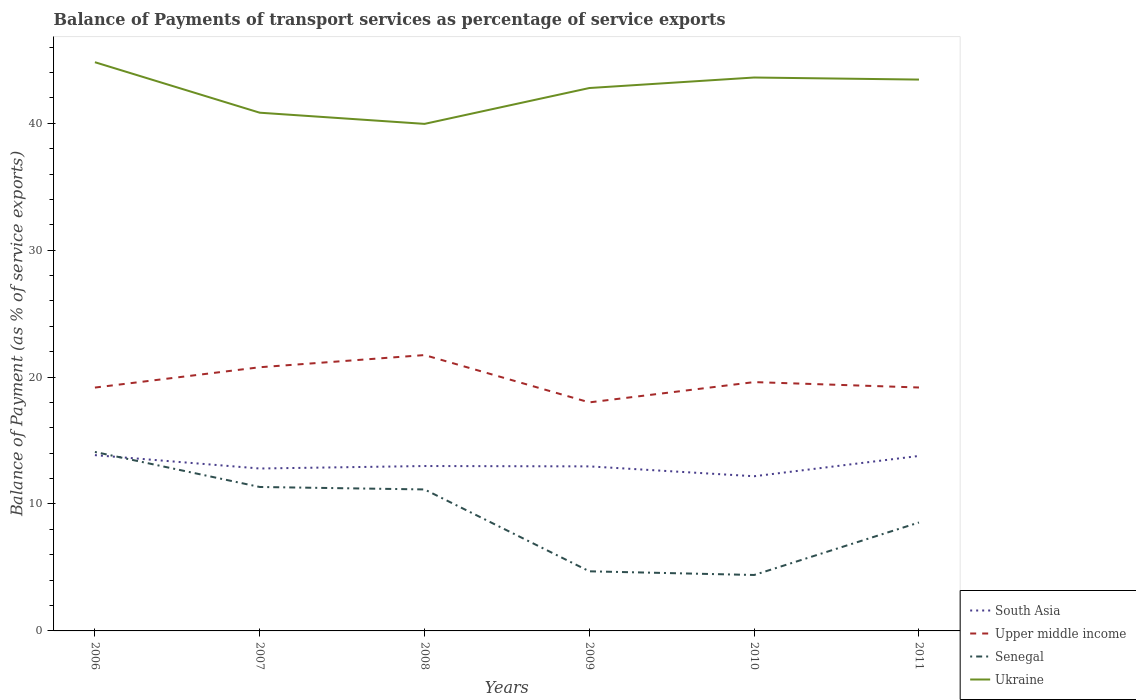Does the line corresponding to Upper middle income intersect with the line corresponding to Senegal?
Offer a terse response. No. Across all years, what is the maximum balance of payments of transport services in Ukraine?
Your answer should be compact. 39.95. In which year was the balance of payments of transport services in South Asia maximum?
Offer a very short reply. 2010. What is the total balance of payments of transport services in Ukraine in the graph?
Your answer should be compact. -3.65. What is the difference between the highest and the second highest balance of payments of transport services in Ukraine?
Provide a short and direct response. 4.86. Is the balance of payments of transport services in Upper middle income strictly greater than the balance of payments of transport services in Senegal over the years?
Your answer should be very brief. No. Are the values on the major ticks of Y-axis written in scientific E-notation?
Offer a very short reply. No. Does the graph contain any zero values?
Your answer should be compact. No. Does the graph contain grids?
Provide a succinct answer. No. How are the legend labels stacked?
Make the answer very short. Vertical. What is the title of the graph?
Ensure brevity in your answer.  Balance of Payments of transport services as percentage of service exports. What is the label or title of the X-axis?
Your answer should be very brief. Years. What is the label or title of the Y-axis?
Your answer should be compact. Balance of Payment (as % of service exports). What is the Balance of Payment (as % of service exports) of South Asia in 2006?
Offer a very short reply. 13.85. What is the Balance of Payment (as % of service exports) of Upper middle income in 2006?
Keep it short and to the point. 19.17. What is the Balance of Payment (as % of service exports) in Senegal in 2006?
Keep it short and to the point. 14.1. What is the Balance of Payment (as % of service exports) in Ukraine in 2006?
Your response must be concise. 44.81. What is the Balance of Payment (as % of service exports) in South Asia in 2007?
Keep it short and to the point. 12.8. What is the Balance of Payment (as % of service exports) in Upper middle income in 2007?
Make the answer very short. 20.77. What is the Balance of Payment (as % of service exports) of Senegal in 2007?
Your answer should be compact. 11.34. What is the Balance of Payment (as % of service exports) of Ukraine in 2007?
Keep it short and to the point. 40.83. What is the Balance of Payment (as % of service exports) of South Asia in 2008?
Your answer should be compact. 12.99. What is the Balance of Payment (as % of service exports) of Upper middle income in 2008?
Give a very brief answer. 21.73. What is the Balance of Payment (as % of service exports) in Senegal in 2008?
Provide a short and direct response. 11.15. What is the Balance of Payment (as % of service exports) in Ukraine in 2008?
Your response must be concise. 39.95. What is the Balance of Payment (as % of service exports) in South Asia in 2009?
Provide a short and direct response. 12.96. What is the Balance of Payment (as % of service exports) of Upper middle income in 2009?
Keep it short and to the point. 18.01. What is the Balance of Payment (as % of service exports) in Senegal in 2009?
Offer a terse response. 4.7. What is the Balance of Payment (as % of service exports) in Ukraine in 2009?
Make the answer very short. 42.77. What is the Balance of Payment (as % of service exports) of South Asia in 2010?
Your answer should be very brief. 12.19. What is the Balance of Payment (as % of service exports) of Upper middle income in 2010?
Offer a very short reply. 19.6. What is the Balance of Payment (as % of service exports) in Senegal in 2010?
Offer a terse response. 4.41. What is the Balance of Payment (as % of service exports) of Ukraine in 2010?
Make the answer very short. 43.6. What is the Balance of Payment (as % of service exports) in South Asia in 2011?
Keep it short and to the point. 13.79. What is the Balance of Payment (as % of service exports) in Upper middle income in 2011?
Offer a very short reply. 19.18. What is the Balance of Payment (as % of service exports) in Senegal in 2011?
Your answer should be compact. 8.54. What is the Balance of Payment (as % of service exports) of Ukraine in 2011?
Your response must be concise. 43.44. Across all years, what is the maximum Balance of Payment (as % of service exports) of South Asia?
Give a very brief answer. 13.85. Across all years, what is the maximum Balance of Payment (as % of service exports) in Upper middle income?
Your answer should be compact. 21.73. Across all years, what is the maximum Balance of Payment (as % of service exports) of Senegal?
Provide a succinct answer. 14.1. Across all years, what is the maximum Balance of Payment (as % of service exports) in Ukraine?
Your response must be concise. 44.81. Across all years, what is the minimum Balance of Payment (as % of service exports) of South Asia?
Your response must be concise. 12.19. Across all years, what is the minimum Balance of Payment (as % of service exports) of Upper middle income?
Keep it short and to the point. 18.01. Across all years, what is the minimum Balance of Payment (as % of service exports) in Senegal?
Your answer should be compact. 4.41. Across all years, what is the minimum Balance of Payment (as % of service exports) in Ukraine?
Ensure brevity in your answer.  39.95. What is the total Balance of Payment (as % of service exports) of South Asia in the graph?
Your answer should be compact. 78.58. What is the total Balance of Payment (as % of service exports) of Upper middle income in the graph?
Ensure brevity in your answer.  118.47. What is the total Balance of Payment (as % of service exports) of Senegal in the graph?
Your answer should be very brief. 54.24. What is the total Balance of Payment (as % of service exports) of Ukraine in the graph?
Your response must be concise. 255.4. What is the difference between the Balance of Payment (as % of service exports) in South Asia in 2006 and that in 2007?
Provide a short and direct response. 1.05. What is the difference between the Balance of Payment (as % of service exports) of Upper middle income in 2006 and that in 2007?
Provide a short and direct response. -1.6. What is the difference between the Balance of Payment (as % of service exports) of Senegal in 2006 and that in 2007?
Offer a very short reply. 2.76. What is the difference between the Balance of Payment (as % of service exports) in Ukraine in 2006 and that in 2007?
Offer a very short reply. 3.98. What is the difference between the Balance of Payment (as % of service exports) of South Asia in 2006 and that in 2008?
Your answer should be compact. 0.86. What is the difference between the Balance of Payment (as % of service exports) in Upper middle income in 2006 and that in 2008?
Provide a short and direct response. -2.56. What is the difference between the Balance of Payment (as % of service exports) of Senegal in 2006 and that in 2008?
Your answer should be compact. 2.95. What is the difference between the Balance of Payment (as % of service exports) of Ukraine in 2006 and that in 2008?
Your response must be concise. 4.86. What is the difference between the Balance of Payment (as % of service exports) of South Asia in 2006 and that in 2009?
Make the answer very short. 0.89. What is the difference between the Balance of Payment (as % of service exports) of Upper middle income in 2006 and that in 2009?
Your answer should be very brief. 1.17. What is the difference between the Balance of Payment (as % of service exports) of Senegal in 2006 and that in 2009?
Provide a short and direct response. 9.4. What is the difference between the Balance of Payment (as % of service exports) in Ukraine in 2006 and that in 2009?
Provide a succinct answer. 2.03. What is the difference between the Balance of Payment (as % of service exports) in South Asia in 2006 and that in 2010?
Your response must be concise. 1.66. What is the difference between the Balance of Payment (as % of service exports) in Upper middle income in 2006 and that in 2010?
Provide a succinct answer. -0.43. What is the difference between the Balance of Payment (as % of service exports) of Senegal in 2006 and that in 2010?
Your answer should be compact. 9.69. What is the difference between the Balance of Payment (as % of service exports) of Ukraine in 2006 and that in 2010?
Make the answer very short. 1.21. What is the difference between the Balance of Payment (as % of service exports) in South Asia in 2006 and that in 2011?
Your response must be concise. 0.06. What is the difference between the Balance of Payment (as % of service exports) of Upper middle income in 2006 and that in 2011?
Make the answer very short. -0.01. What is the difference between the Balance of Payment (as % of service exports) in Senegal in 2006 and that in 2011?
Give a very brief answer. 5.56. What is the difference between the Balance of Payment (as % of service exports) in Ukraine in 2006 and that in 2011?
Your answer should be very brief. 1.37. What is the difference between the Balance of Payment (as % of service exports) of South Asia in 2007 and that in 2008?
Keep it short and to the point. -0.19. What is the difference between the Balance of Payment (as % of service exports) of Upper middle income in 2007 and that in 2008?
Offer a terse response. -0.96. What is the difference between the Balance of Payment (as % of service exports) in Senegal in 2007 and that in 2008?
Provide a succinct answer. 0.19. What is the difference between the Balance of Payment (as % of service exports) of Ukraine in 2007 and that in 2008?
Provide a short and direct response. 0.88. What is the difference between the Balance of Payment (as % of service exports) of South Asia in 2007 and that in 2009?
Give a very brief answer. -0.17. What is the difference between the Balance of Payment (as % of service exports) in Upper middle income in 2007 and that in 2009?
Your response must be concise. 2.77. What is the difference between the Balance of Payment (as % of service exports) of Senegal in 2007 and that in 2009?
Provide a succinct answer. 6.64. What is the difference between the Balance of Payment (as % of service exports) of Ukraine in 2007 and that in 2009?
Your answer should be compact. -1.94. What is the difference between the Balance of Payment (as % of service exports) of South Asia in 2007 and that in 2010?
Give a very brief answer. 0.61. What is the difference between the Balance of Payment (as % of service exports) in Upper middle income in 2007 and that in 2010?
Provide a succinct answer. 1.17. What is the difference between the Balance of Payment (as % of service exports) in Senegal in 2007 and that in 2010?
Offer a terse response. 6.93. What is the difference between the Balance of Payment (as % of service exports) in Ukraine in 2007 and that in 2010?
Your answer should be very brief. -2.77. What is the difference between the Balance of Payment (as % of service exports) in South Asia in 2007 and that in 2011?
Make the answer very short. -0.99. What is the difference between the Balance of Payment (as % of service exports) in Upper middle income in 2007 and that in 2011?
Provide a succinct answer. 1.6. What is the difference between the Balance of Payment (as % of service exports) in Senegal in 2007 and that in 2011?
Offer a very short reply. 2.8. What is the difference between the Balance of Payment (as % of service exports) of Ukraine in 2007 and that in 2011?
Provide a short and direct response. -2.61. What is the difference between the Balance of Payment (as % of service exports) in South Asia in 2008 and that in 2009?
Offer a very short reply. 0.03. What is the difference between the Balance of Payment (as % of service exports) in Upper middle income in 2008 and that in 2009?
Offer a terse response. 3.73. What is the difference between the Balance of Payment (as % of service exports) of Senegal in 2008 and that in 2009?
Offer a very short reply. 6.45. What is the difference between the Balance of Payment (as % of service exports) of Ukraine in 2008 and that in 2009?
Ensure brevity in your answer.  -2.82. What is the difference between the Balance of Payment (as % of service exports) in South Asia in 2008 and that in 2010?
Keep it short and to the point. 0.81. What is the difference between the Balance of Payment (as % of service exports) of Upper middle income in 2008 and that in 2010?
Ensure brevity in your answer.  2.13. What is the difference between the Balance of Payment (as % of service exports) in Senegal in 2008 and that in 2010?
Ensure brevity in your answer.  6.74. What is the difference between the Balance of Payment (as % of service exports) in Ukraine in 2008 and that in 2010?
Ensure brevity in your answer.  -3.65. What is the difference between the Balance of Payment (as % of service exports) in South Asia in 2008 and that in 2011?
Offer a very short reply. -0.79. What is the difference between the Balance of Payment (as % of service exports) of Upper middle income in 2008 and that in 2011?
Your response must be concise. 2.56. What is the difference between the Balance of Payment (as % of service exports) of Senegal in 2008 and that in 2011?
Your answer should be very brief. 2.6. What is the difference between the Balance of Payment (as % of service exports) in Ukraine in 2008 and that in 2011?
Offer a very short reply. -3.49. What is the difference between the Balance of Payment (as % of service exports) in South Asia in 2009 and that in 2010?
Your answer should be compact. 0.78. What is the difference between the Balance of Payment (as % of service exports) in Upper middle income in 2009 and that in 2010?
Ensure brevity in your answer.  -1.6. What is the difference between the Balance of Payment (as % of service exports) of Senegal in 2009 and that in 2010?
Give a very brief answer. 0.29. What is the difference between the Balance of Payment (as % of service exports) in Ukraine in 2009 and that in 2010?
Provide a succinct answer. -0.83. What is the difference between the Balance of Payment (as % of service exports) in South Asia in 2009 and that in 2011?
Offer a terse response. -0.82. What is the difference between the Balance of Payment (as % of service exports) of Upper middle income in 2009 and that in 2011?
Your answer should be very brief. -1.17. What is the difference between the Balance of Payment (as % of service exports) in Senegal in 2009 and that in 2011?
Your answer should be very brief. -3.85. What is the difference between the Balance of Payment (as % of service exports) of Ukraine in 2009 and that in 2011?
Keep it short and to the point. -0.66. What is the difference between the Balance of Payment (as % of service exports) in South Asia in 2010 and that in 2011?
Your answer should be compact. -1.6. What is the difference between the Balance of Payment (as % of service exports) of Upper middle income in 2010 and that in 2011?
Your answer should be compact. 0.43. What is the difference between the Balance of Payment (as % of service exports) in Senegal in 2010 and that in 2011?
Ensure brevity in your answer.  -4.14. What is the difference between the Balance of Payment (as % of service exports) of Ukraine in 2010 and that in 2011?
Provide a short and direct response. 0.16. What is the difference between the Balance of Payment (as % of service exports) of South Asia in 2006 and the Balance of Payment (as % of service exports) of Upper middle income in 2007?
Make the answer very short. -6.92. What is the difference between the Balance of Payment (as % of service exports) of South Asia in 2006 and the Balance of Payment (as % of service exports) of Senegal in 2007?
Offer a terse response. 2.51. What is the difference between the Balance of Payment (as % of service exports) in South Asia in 2006 and the Balance of Payment (as % of service exports) in Ukraine in 2007?
Provide a succinct answer. -26.98. What is the difference between the Balance of Payment (as % of service exports) of Upper middle income in 2006 and the Balance of Payment (as % of service exports) of Senegal in 2007?
Offer a terse response. 7.83. What is the difference between the Balance of Payment (as % of service exports) of Upper middle income in 2006 and the Balance of Payment (as % of service exports) of Ukraine in 2007?
Make the answer very short. -21.66. What is the difference between the Balance of Payment (as % of service exports) of Senegal in 2006 and the Balance of Payment (as % of service exports) of Ukraine in 2007?
Provide a succinct answer. -26.73. What is the difference between the Balance of Payment (as % of service exports) in South Asia in 2006 and the Balance of Payment (as % of service exports) in Upper middle income in 2008?
Make the answer very short. -7.88. What is the difference between the Balance of Payment (as % of service exports) of South Asia in 2006 and the Balance of Payment (as % of service exports) of Senegal in 2008?
Provide a short and direct response. 2.7. What is the difference between the Balance of Payment (as % of service exports) in South Asia in 2006 and the Balance of Payment (as % of service exports) in Ukraine in 2008?
Your response must be concise. -26.1. What is the difference between the Balance of Payment (as % of service exports) of Upper middle income in 2006 and the Balance of Payment (as % of service exports) of Senegal in 2008?
Provide a short and direct response. 8.03. What is the difference between the Balance of Payment (as % of service exports) in Upper middle income in 2006 and the Balance of Payment (as % of service exports) in Ukraine in 2008?
Give a very brief answer. -20.78. What is the difference between the Balance of Payment (as % of service exports) in Senegal in 2006 and the Balance of Payment (as % of service exports) in Ukraine in 2008?
Provide a succinct answer. -25.85. What is the difference between the Balance of Payment (as % of service exports) of South Asia in 2006 and the Balance of Payment (as % of service exports) of Upper middle income in 2009?
Make the answer very short. -4.16. What is the difference between the Balance of Payment (as % of service exports) of South Asia in 2006 and the Balance of Payment (as % of service exports) of Senegal in 2009?
Give a very brief answer. 9.15. What is the difference between the Balance of Payment (as % of service exports) in South Asia in 2006 and the Balance of Payment (as % of service exports) in Ukraine in 2009?
Keep it short and to the point. -28.92. What is the difference between the Balance of Payment (as % of service exports) of Upper middle income in 2006 and the Balance of Payment (as % of service exports) of Senegal in 2009?
Give a very brief answer. 14.48. What is the difference between the Balance of Payment (as % of service exports) in Upper middle income in 2006 and the Balance of Payment (as % of service exports) in Ukraine in 2009?
Offer a terse response. -23.6. What is the difference between the Balance of Payment (as % of service exports) in Senegal in 2006 and the Balance of Payment (as % of service exports) in Ukraine in 2009?
Keep it short and to the point. -28.67. What is the difference between the Balance of Payment (as % of service exports) of South Asia in 2006 and the Balance of Payment (as % of service exports) of Upper middle income in 2010?
Ensure brevity in your answer.  -5.75. What is the difference between the Balance of Payment (as % of service exports) of South Asia in 2006 and the Balance of Payment (as % of service exports) of Senegal in 2010?
Give a very brief answer. 9.44. What is the difference between the Balance of Payment (as % of service exports) of South Asia in 2006 and the Balance of Payment (as % of service exports) of Ukraine in 2010?
Provide a succinct answer. -29.75. What is the difference between the Balance of Payment (as % of service exports) of Upper middle income in 2006 and the Balance of Payment (as % of service exports) of Senegal in 2010?
Offer a terse response. 14.77. What is the difference between the Balance of Payment (as % of service exports) in Upper middle income in 2006 and the Balance of Payment (as % of service exports) in Ukraine in 2010?
Ensure brevity in your answer.  -24.43. What is the difference between the Balance of Payment (as % of service exports) in Senegal in 2006 and the Balance of Payment (as % of service exports) in Ukraine in 2010?
Give a very brief answer. -29.5. What is the difference between the Balance of Payment (as % of service exports) in South Asia in 2006 and the Balance of Payment (as % of service exports) in Upper middle income in 2011?
Your answer should be compact. -5.33. What is the difference between the Balance of Payment (as % of service exports) in South Asia in 2006 and the Balance of Payment (as % of service exports) in Senegal in 2011?
Provide a succinct answer. 5.31. What is the difference between the Balance of Payment (as % of service exports) of South Asia in 2006 and the Balance of Payment (as % of service exports) of Ukraine in 2011?
Give a very brief answer. -29.59. What is the difference between the Balance of Payment (as % of service exports) of Upper middle income in 2006 and the Balance of Payment (as % of service exports) of Senegal in 2011?
Keep it short and to the point. 10.63. What is the difference between the Balance of Payment (as % of service exports) of Upper middle income in 2006 and the Balance of Payment (as % of service exports) of Ukraine in 2011?
Your answer should be very brief. -24.27. What is the difference between the Balance of Payment (as % of service exports) in Senegal in 2006 and the Balance of Payment (as % of service exports) in Ukraine in 2011?
Offer a very short reply. -29.34. What is the difference between the Balance of Payment (as % of service exports) in South Asia in 2007 and the Balance of Payment (as % of service exports) in Upper middle income in 2008?
Provide a succinct answer. -8.94. What is the difference between the Balance of Payment (as % of service exports) of South Asia in 2007 and the Balance of Payment (as % of service exports) of Senegal in 2008?
Ensure brevity in your answer.  1.65. What is the difference between the Balance of Payment (as % of service exports) of South Asia in 2007 and the Balance of Payment (as % of service exports) of Ukraine in 2008?
Your answer should be very brief. -27.15. What is the difference between the Balance of Payment (as % of service exports) of Upper middle income in 2007 and the Balance of Payment (as % of service exports) of Senegal in 2008?
Give a very brief answer. 9.63. What is the difference between the Balance of Payment (as % of service exports) in Upper middle income in 2007 and the Balance of Payment (as % of service exports) in Ukraine in 2008?
Your answer should be compact. -19.17. What is the difference between the Balance of Payment (as % of service exports) of Senegal in 2007 and the Balance of Payment (as % of service exports) of Ukraine in 2008?
Ensure brevity in your answer.  -28.61. What is the difference between the Balance of Payment (as % of service exports) of South Asia in 2007 and the Balance of Payment (as % of service exports) of Upper middle income in 2009?
Keep it short and to the point. -5.21. What is the difference between the Balance of Payment (as % of service exports) of South Asia in 2007 and the Balance of Payment (as % of service exports) of Senegal in 2009?
Ensure brevity in your answer.  8.1. What is the difference between the Balance of Payment (as % of service exports) in South Asia in 2007 and the Balance of Payment (as % of service exports) in Ukraine in 2009?
Provide a succinct answer. -29.98. What is the difference between the Balance of Payment (as % of service exports) of Upper middle income in 2007 and the Balance of Payment (as % of service exports) of Senegal in 2009?
Offer a very short reply. 16.08. What is the difference between the Balance of Payment (as % of service exports) of Upper middle income in 2007 and the Balance of Payment (as % of service exports) of Ukraine in 2009?
Make the answer very short. -22. What is the difference between the Balance of Payment (as % of service exports) in Senegal in 2007 and the Balance of Payment (as % of service exports) in Ukraine in 2009?
Ensure brevity in your answer.  -31.43. What is the difference between the Balance of Payment (as % of service exports) of South Asia in 2007 and the Balance of Payment (as % of service exports) of Upper middle income in 2010?
Make the answer very short. -6.81. What is the difference between the Balance of Payment (as % of service exports) of South Asia in 2007 and the Balance of Payment (as % of service exports) of Senegal in 2010?
Your answer should be compact. 8.39. What is the difference between the Balance of Payment (as % of service exports) of South Asia in 2007 and the Balance of Payment (as % of service exports) of Ukraine in 2010?
Your response must be concise. -30.81. What is the difference between the Balance of Payment (as % of service exports) in Upper middle income in 2007 and the Balance of Payment (as % of service exports) in Senegal in 2010?
Offer a very short reply. 16.37. What is the difference between the Balance of Payment (as % of service exports) of Upper middle income in 2007 and the Balance of Payment (as % of service exports) of Ukraine in 2010?
Provide a succinct answer. -22.83. What is the difference between the Balance of Payment (as % of service exports) in Senegal in 2007 and the Balance of Payment (as % of service exports) in Ukraine in 2010?
Your answer should be very brief. -32.26. What is the difference between the Balance of Payment (as % of service exports) in South Asia in 2007 and the Balance of Payment (as % of service exports) in Upper middle income in 2011?
Offer a very short reply. -6.38. What is the difference between the Balance of Payment (as % of service exports) in South Asia in 2007 and the Balance of Payment (as % of service exports) in Senegal in 2011?
Provide a short and direct response. 4.25. What is the difference between the Balance of Payment (as % of service exports) of South Asia in 2007 and the Balance of Payment (as % of service exports) of Ukraine in 2011?
Your answer should be very brief. -30.64. What is the difference between the Balance of Payment (as % of service exports) of Upper middle income in 2007 and the Balance of Payment (as % of service exports) of Senegal in 2011?
Make the answer very short. 12.23. What is the difference between the Balance of Payment (as % of service exports) in Upper middle income in 2007 and the Balance of Payment (as % of service exports) in Ukraine in 2011?
Give a very brief answer. -22.66. What is the difference between the Balance of Payment (as % of service exports) in Senegal in 2007 and the Balance of Payment (as % of service exports) in Ukraine in 2011?
Give a very brief answer. -32.1. What is the difference between the Balance of Payment (as % of service exports) of South Asia in 2008 and the Balance of Payment (as % of service exports) of Upper middle income in 2009?
Keep it short and to the point. -5.01. What is the difference between the Balance of Payment (as % of service exports) in South Asia in 2008 and the Balance of Payment (as % of service exports) in Senegal in 2009?
Your response must be concise. 8.3. What is the difference between the Balance of Payment (as % of service exports) in South Asia in 2008 and the Balance of Payment (as % of service exports) in Ukraine in 2009?
Make the answer very short. -29.78. What is the difference between the Balance of Payment (as % of service exports) in Upper middle income in 2008 and the Balance of Payment (as % of service exports) in Senegal in 2009?
Your response must be concise. 17.04. What is the difference between the Balance of Payment (as % of service exports) of Upper middle income in 2008 and the Balance of Payment (as % of service exports) of Ukraine in 2009?
Offer a very short reply. -21.04. What is the difference between the Balance of Payment (as % of service exports) in Senegal in 2008 and the Balance of Payment (as % of service exports) in Ukraine in 2009?
Provide a succinct answer. -31.63. What is the difference between the Balance of Payment (as % of service exports) of South Asia in 2008 and the Balance of Payment (as % of service exports) of Upper middle income in 2010?
Offer a very short reply. -6.61. What is the difference between the Balance of Payment (as % of service exports) of South Asia in 2008 and the Balance of Payment (as % of service exports) of Senegal in 2010?
Make the answer very short. 8.58. What is the difference between the Balance of Payment (as % of service exports) of South Asia in 2008 and the Balance of Payment (as % of service exports) of Ukraine in 2010?
Make the answer very short. -30.61. What is the difference between the Balance of Payment (as % of service exports) of Upper middle income in 2008 and the Balance of Payment (as % of service exports) of Senegal in 2010?
Give a very brief answer. 17.33. What is the difference between the Balance of Payment (as % of service exports) of Upper middle income in 2008 and the Balance of Payment (as % of service exports) of Ukraine in 2010?
Offer a very short reply. -21.87. What is the difference between the Balance of Payment (as % of service exports) of Senegal in 2008 and the Balance of Payment (as % of service exports) of Ukraine in 2010?
Your answer should be compact. -32.46. What is the difference between the Balance of Payment (as % of service exports) in South Asia in 2008 and the Balance of Payment (as % of service exports) in Upper middle income in 2011?
Provide a short and direct response. -6.19. What is the difference between the Balance of Payment (as % of service exports) of South Asia in 2008 and the Balance of Payment (as % of service exports) of Senegal in 2011?
Your answer should be very brief. 4.45. What is the difference between the Balance of Payment (as % of service exports) of South Asia in 2008 and the Balance of Payment (as % of service exports) of Ukraine in 2011?
Offer a terse response. -30.45. What is the difference between the Balance of Payment (as % of service exports) of Upper middle income in 2008 and the Balance of Payment (as % of service exports) of Senegal in 2011?
Keep it short and to the point. 13.19. What is the difference between the Balance of Payment (as % of service exports) in Upper middle income in 2008 and the Balance of Payment (as % of service exports) in Ukraine in 2011?
Provide a short and direct response. -21.7. What is the difference between the Balance of Payment (as % of service exports) of Senegal in 2008 and the Balance of Payment (as % of service exports) of Ukraine in 2011?
Your answer should be very brief. -32.29. What is the difference between the Balance of Payment (as % of service exports) of South Asia in 2009 and the Balance of Payment (as % of service exports) of Upper middle income in 2010?
Give a very brief answer. -6.64. What is the difference between the Balance of Payment (as % of service exports) of South Asia in 2009 and the Balance of Payment (as % of service exports) of Senegal in 2010?
Ensure brevity in your answer.  8.56. What is the difference between the Balance of Payment (as % of service exports) in South Asia in 2009 and the Balance of Payment (as % of service exports) in Ukraine in 2010?
Give a very brief answer. -30.64. What is the difference between the Balance of Payment (as % of service exports) of Upper middle income in 2009 and the Balance of Payment (as % of service exports) of Senegal in 2010?
Make the answer very short. 13.6. What is the difference between the Balance of Payment (as % of service exports) of Upper middle income in 2009 and the Balance of Payment (as % of service exports) of Ukraine in 2010?
Offer a terse response. -25.6. What is the difference between the Balance of Payment (as % of service exports) of Senegal in 2009 and the Balance of Payment (as % of service exports) of Ukraine in 2010?
Give a very brief answer. -38.91. What is the difference between the Balance of Payment (as % of service exports) of South Asia in 2009 and the Balance of Payment (as % of service exports) of Upper middle income in 2011?
Provide a succinct answer. -6.21. What is the difference between the Balance of Payment (as % of service exports) in South Asia in 2009 and the Balance of Payment (as % of service exports) in Senegal in 2011?
Provide a succinct answer. 4.42. What is the difference between the Balance of Payment (as % of service exports) in South Asia in 2009 and the Balance of Payment (as % of service exports) in Ukraine in 2011?
Offer a terse response. -30.47. What is the difference between the Balance of Payment (as % of service exports) of Upper middle income in 2009 and the Balance of Payment (as % of service exports) of Senegal in 2011?
Give a very brief answer. 9.46. What is the difference between the Balance of Payment (as % of service exports) of Upper middle income in 2009 and the Balance of Payment (as % of service exports) of Ukraine in 2011?
Keep it short and to the point. -25.43. What is the difference between the Balance of Payment (as % of service exports) of Senegal in 2009 and the Balance of Payment (as % of service exports) of Ukraine in 2011?
Provide a short and direct response. -38.74. What is the difference between the Balance of Payment (as % of service exports) in South Asia in 2010 and the Balance of Payment (as % of service exports) in Upper middle income in 2011?
Provide a short and direct response. -6.99. What is the difference between the Balance of Payment (as % of service exports) of South Asia in 2010 and the Balance of Payment (as % of service exports) of Senegal in 2011?
Provide a succinct answer. 3.64. What is the difference between the Balance of Payment (as % of service exports) of South Asia in 2010 and the Balance of Payment (as % of service exports) of Ukraine in 2011?
Make the answer very short. -31.25. What is the difference between the Balance of Payment (as % of service exports) of Upper middle income in 2010 and the Balance of Payment (as % of service exports) of Senegal in 2011?
Make the answer very short. 11.06. What is the difference between the Balance of Payment (as % of service exports) in Upper middle income in 2010 and the Balance of Payment (as % of service exports) in Ukraine in 2011?
Ensure brevity in your answer.  -23.83. What is the difference between the Balance of Payment (as % of service exports) in Senegal in 2010 and the Balance of Payment (as % of service exports) in Ukraine in 2011?
Your response must be concise. -39.03. What is the average Balance of Payment (as % of service exports) in South Asia per year?
Make the answer very short. 13.1. What is the average Balance of Payment (as % of service exports) of Upper middle income per year?
Keep it short and to the point. 19.75. What is the average Balance of Payment (as % of service exports) in Senegal per year?
Ensure brevity in your answer.  9.04. What is the average Balance of Payment (as % of service exports) of Ukraine per year?
Ensure brevity in your answer.  42.57. In the year 2006, what is the difference between the Balance of Payment (as % of service exports) in South Asia and Balance of Payment (as % of service exports) in Upper middle income?
Provide a succinct answer. -5.32. In the year 2006, what is the difference between the Balance of Payment (as % of service exports) in South Asia and Balance of Payment (as % of service exports) in Senegal?
Make the answer very short. -0.25. In the year 2006, what is the difference between the Balance of Payment (as % of service exports) of South Asia and Balance of Payment (as % of service exports) of Ukraine?
Make the answer very short. -30.96. In the year 2006, what is the difference between the Balance of Payment (as % of service exports) in Upper middle income and Balance of Payment (as % of service exports) in Senegal?
Make the answer very short. 5.07. In the year 2006, what is the difference between the Balance of Payment (as % of service exports) of Upper middle income and Balance of Payment (as % of service exports) of Ukraine?
Offer a very short reply. -25.63. In the year 2006, what is the difference between the Balance of Payment (as % of service exports) in Senegal and Balance of Payment (as % of service exports) in Ukraine?
Offer a very short reply. -30.71. In the year 2007, what is the difference between the Balance of Payment (as % of service exports) in South Asia and Balance of Payment (as % of service exports) in Upper middle income?
Offer a very short reply. -7.98. In the year 2007, what is the difference between the Balance of Payment (as % of service exports) in South Asia and Balance of Payment (as % of service exports) in Senegal?
Offer a very short reply. 1.46. In the year 2007, what is the difference between the Balance of Payment (as % of service exports) of South Asia and Balance of Payment (as % of service exports) of Ukraine?
Your answer should be very brief. -28.03. In the year 2007, what is the difference between the Balance of Payment (as % of service exports) in Upper middle income and Balance of Payment (as % of service exports) in Senegal?
Provide a short and direct response. 9.43. In the year 2007, what is the difference between the Balance of Payment (as % of service exports) in Upper middle income and Balance of Payment (as % of service exports) in Ukraine?
Your answer should be compact. -20.05. In the year 2007, what is the difference between the Balance of Payment (as % of service exports) in Senegal and Balance of Payment (as % of service exports) in Ukraine?
Your response must be concise. -29.49. In the year 2008, what is the difference between the Balance of Payment (as % of service exports) in South Asia and Balance of Payment (as % of service exports) in Upper middle income?
Keep it short and to the point. -8.74. In the year 2008, what is the difference between the Balance of Payment (as % of service exports) of South Asia and Balance of Payment (as % of service exports) of Senegal?
Keep it short and to the point. 1.84. In the year 2008, what is the difference between the Balance of Payment (as % of service exports) of South Asia and Balance of Payment (as % of service exports) of Ukraine?
Offer a very short reply. -26.96. In the year 2008, what is the difference between the Balance of Payment (as % of service exports) in Upper middle income and Balance of Payment (as % of service exports) in Senegal?
Make the answer very short. 10.59. In the year 2008, what is the difference between the Balance of Payment (as % of service exports) of Upper middle income and Balance of Payment (as % of service exports) of Ukraine?
Ensure brevity in your answer.  -18.22. In the year 2008, what is the difference between the Balance of Payment (as % of service exports) of Senegal and Balance of Payment (as % of service exports) of Ukraine?
Offer a terse response. -28.8. In the year 2009, what is the difference between the Balance of Payment (as % of service exports) in South Asia and Balance of Payment (as % of service exports) in Upper middle income?
Keep it short and to the point. -5.04. In the year 2009, what is the difference between the Balance of Payment (as % of service exports) of South Asia and Balance of Payment (as % of service exports) of Senegal?
Ensure brevity in your answer.  8.27. In the year 2009, what is the difference between the Balance of Payment (as % of service exports) in South Asia and Balance of Payment (as % of service exports) in Ukraine?
Offer a terse response. -29.81. In the year 2009, what is the difference between the Balance of Payment (as % of service exports) of Upper middle income and Balance of Payment (as % of service exports) of Senegal?
Offer a terse response. 13.31. In the year 2009, what is the difference between the Balance of Payment (as % of service exports) of Upper middle income and Balance of Payment (as % of service exports) of Ukraine?
Your response must be concise. -24.77. In the year 2009, what is the difference between the Balance of Payment (as % of service exports) of Senegal and Balance of Payment (as % of service exports) of Ukraine?
Give a very brief answer. -38.08. In the year 2010, what is the difference between the Balance of Payment (as % of service exports) in South Asia and Balance of Payment (as % of service exports) in Upper middle income?
Ensure brevity in your answer.  -7.42. In the year 2010, what is the difference between the Balance of Payment (as % of service exports) of South Asia and Balance of Payment (as % of service exports) of Senegal?
Provide a short and direct response. 7.78. In the year 2010, what is the difference between the Balance of Payment (as % of service exports) in South Asia and Balance of Payment (as % of service exports) in Ukraine?
Your answer should be very brief. -31.42. In the year 2010, what is the difference between the Balance of Payment (as % of service exports) in Upper middle income and Balance of Payment (as % of service exports) in Senegal?
Keep it short and to the point. 15.2. In the year 2010, what is the difference between the Balance of Payment (as % of service exports) of Upper middle income and Balance of Payment (as % of service exports) of Ukraine?
Offer a very short reply. -24. In the year 2010, what is the difference between the Balance of Payment (as % of service exports) of Senegal and Balance of Payment (as % of service exports) of Ukraine?
Provide a succinct answer. -39.2. In the year 2011, what is the difference between the Balance of Payment (as % of service exports) in South Asia and Balance of Payment (as % of service exports) in Upper middle income?
Provide a short and direct response. -5.39. In the year 2011, what is the difference between the Balance of Payment (as % of service exports) of South Asia and Balance of Payment (as % of service exports) of Senegal?
Make the answer very short. 5.24. In the year 2011, what is the difference between the Balance of Payment (as % of service exports) in South Asia and Balance of Payment (as % of service exports) in Ukraine?
Offer a terse response. -29.65. In the year 2011, what is the difference between the Balance of Payment (as % of service exports) in Upper middle income and Balance of Payment (as % of service exports) in Senegal?
Provide a short and direct response. 10.64. In the year 2011, what is the difference between the Balance of Payment (as % of service exports) of Upper middle income and Balance of Payment (as % of service exports) of Ukraine?
Provide a short and direct response. -24.26. In the year 2011, what is the difference between the Balance of Payment (as % of service exports) in Senegal and Balance of Payment (as % of service exports) in Ukraine?
Provide a short and direct response. -34.9. What is the ratio of the Balance of Payment (as % of service exports) in South Asia in 2006 to that in 2007?
Keep it short and to the point. 1.08. What is the ratio of the Balance of Payment (as % of service exports) of Upper middle income in 2006 to that in 2007?
Keep it short and to the point. 0.92. What is the ratio of the Balance of Payment (as % of service exports) of Senegal in 2006 to that in 2007?
Keep it short and to the point. 1.24. What is the ratio of the Balance of Payment (as % of service exports) of Ukraine in 2006 to that in 2007?
Offer a very short reply. 1.1. What is the ratio of the Balance of Payment (as % of service exports) in South Asia in 2006 to that in 2008?
Offer a very short reply. 1.07. What is the ratio of the Balance of Payment (as % of service exports) in Upper middle income in 2006 to that in 2008?
Provide a short and direct response. 0.88. What is the ratio of the Balance of Payment (as % of service exports) of Senegal in 2006 to that in 2008?
Provide a short and direct response. 1.26. What is the ratio of the Balance of Payment (as % of service exports) of Ukraine in 2006 to that in 2008?
Provide a short and direct response. 1.12. What is the ratio of the Balance of Payment (as % of service exports) in South Asia in 2006 to that in 2009?
Offer a very short reply. 1.07. What is the ratio of the Balance of Payment (as % of service exports) in Upper middle income in 2006 to that in 2009?
Keep it short and to the point. 1.06. What is the ratio of the Balance of Payment (as % of service exports) of Senegal in 2006 to that in 2009?
Your answer should be compact. 3. What is the ratio of the Balance of Payment (as % of service exports) in Ukraine in 2006 to that in 2009?
Give a very brief answer. 1.05. What is the ratio of the Balance of Payment (as % of service exports) of South Asia in 2006 to that in 2010?
Ensure brevity in your answer.  1.14. What is the ratio of the Balance of Payment (as % of service exports) of Senegal in 2006 to that in 2010?
Provide a succinct answer. 3.2. What is the ratio of the Balance of Payment (as % of service exports) of Ukraine in 2006 to that in 2010?
Offer a very short reply. 1.03. What is the ratio of the Balance of Payment (as % of service exports) of South Asia in 2006 to that in 2011?
Your answer should be compact. 1. What is the ratio of the Balance of Payment (as % of service exports) in Senegal in 2006 to that in 2011?
Make the answer very short. 1.65. What is the ratio of the Balance of Payment (as % of service exports) in Ukraine in 2006 to that in 2011?
Your response must be concise. 1.03. What is the ratio of the Balance of Payment (as % of service exports) of Upper middle income in 2007 to that in 2008?
Offer a terse response. 0.96. What is the ratio of the Balance of Payment (as % of service exports) in Senegal in 2007 to that in 2008?
Provide a short and direct response. 1.02. What is the ratio of the Balance of Payment (as % of service exports) in South Asia in 2007 to that in 2009?
Your response must be concise. 0.99. What is the ratio of the Balance of Payment (as % of service exports) in Upper middle income in 2007 to that in 2009?
Give a very brief answer. 1.15. What is the ratio of the Balance of Payment (as % of service exports) in Senegal in 2007 to that in 2009?
Keep it short and to the point. 2.41. What is the ratio of the Balance of Payment (as % of service exports) of Ukraine in 2007 to that in 2009?
Your answer should be compact. 0.95. What is the ratio of the Balance of Payment (as % of service exports) of South Asia in 2007 to that in 2010?
Provide a succinct answer. 1.05. What is the ratio of the Balance of Payment (as % of service exports) in Upper middle income in 2007 to that in 2010?
Your response must be concise. 1.06. What is the ratio of the Balance of Payment (as % of service exports) in Senegal in 2007 to that in 2010?
Your response must be concise. 2.57. What is the ratio of the Balance of Payment (as % of service exports) in Ukraine in 2007 to that in 2010?
Your response must be concise. 0.94. What is the ratio of the Balance of Payment (as % of service exports) of South Asia in 2007 to that in 2011?
Your answer should be very brief. 0.93. What is the ratio of the Balance of Payment (as % of service exports) of Upper middle income in 2007 to that in 2011?
Provide a succinct answer. 1.08. What is the ratio of the Balance of Payment (as % of service exports) in Senegal in 2007 to that in 2011?
Provide a short and direct response. 1.33. What is the ratio of the Balance of Payment (as % of service exports) of Ukraine in 2007 to that in 2011?
Your response must be concise. 0.94. What is the ratio of the Balance of Payment (as % of service exports) in South Asia in 2008 to that in 2009?
Ensure brevity in your answer.  1. What is the ratio of the Balance of Payment (as % of service exports) of Upper middle income in 2008 to that in 2009?
Ensure brevity in your answer.  1.21. What is the ratio of the Balance of Payment (as % of service exports) of Senegal in 2008 to that in 2009?
Your answer should be compact. 2.37. What is the ratio of the Balance of Payment (as % of service exports) in Ukraine in 2008 to that in 2009?
Ensure brevity in your answer.  0.93. What is the ratio of the Balance of Payment (as % of service exports) in South Asia in 2008 to that in 2010?
Keep it short and to the point. 1.07. What is the ratio of the Balance of Payment (as % of service exports) of Upper middle income in 2008 to that in 2010?
Keep it short and to the point. 1.11. What is the ratio of the Balance of Payment (as % of service exports) in Senegal in 2008 to that in 2010?
Offer a terse response. 2.53. What is the ratio of the Balance of Payment (as % of service exports) of Ukraine in 2008 to that in 2010?
Give a very brief answer. 0.92. What is the ratio of the Balance of Payment (as % of service exports) of South Asia in 2008 to that in 2011?
Offer a terse response. 0.94. What is the ratio of the Balance of Payment (as % of service exports) in Upper middle income in 2008 to that in 2011?
Provide a short and direct response. 1.13. What is the ratio of the Balance of Payment (as % of service exports) of Senegal in 2008 to that in 2011?
Provide a succinct answer. 1.3. What is the ratio of the Balance of Payment (as % of service exports) in Ukraine in 2008 to that in 2011?
Your answer should be compact. 0.92. What is the ratio of the Balance of Payment (as % of service exports) in South Asia in 2009 to that in 2010?
Offer a terse response. 1.06. What is the ratio of the Balance of Payment (as % of service exports) in Upper middle income in 2009 to that in 2010?
Provide a short and direct response. 0.92. What is the ratio of the Balance of Payment (as % of service exports) in Senegal in 2009 to that in 2010?
Offer a terse response. 1.07. What is the ratio of the Balance of Payment (as % of service exports) of Ukraine in 2009 to that in 2010?
Ensure brevity in your answer.  0.98. What is the ratio of the Balance of Payment (as % of service exports) of South Asia in 2009 to that in 2011?
Keep it short and to the point. 0.94. What is the ratio of the Balance of Payment (as % of service exports) of Upper middle income in 2009 to that in 2011?
Your answer should be very brief. 0.94. What is the ratio of the Balance of Payment (as % of service exports) in Senegal in 2009 to that in 2011?
Give a very brief answer. 0.55. What is the ratio of the Balance of Payment (as % of service exports) of Ukraine in 2009 to that in 2011?
Keep it short and to the point. 0.98. What is the ratio of the Balance of Payment (as % of service exports) of South Asia in 2010 to that in 2011?
Your answer should be compact. 0.88. What is the ratio of the Balance of Payment (as % of service exports) in Upper middle income in 2010 to that in 2011?
Your answer should be very brief. 1.02. What is the ratio of the Balance of Payment (as % of service exports) of Senegal in 2010 to that in 2011?
Your answer should be very brief. 0.52. What is the difference between the highest and the second highest Balance of Payment (as % of service exports) in South Asia?
Ensure brevity in your answer.  0.06. What is the difference between the highest and the second highest Balance of Payment (as % of service exports) in Upper middle income?
Make the answer very short. 0.96. What is the difference between the highest and the second highest Balance of Payment (as % of service exports) of Senegal?
Offer a terse response. 2.76. What is the difference between the highest and the second highest Balance of Payment (as % of service exports) in Ukraine?
Ensure brevity in your answer.  1.21. What is the difference between the highest and the lowest Balance of Payment (as % of service exports) in South Asia?
Your answer should be very brief. 1.66. What is the difference between the highest and the lowest Balance of Payment (as % of service exports) in Upper middle income?
Offer a very short reply. 3.73. What is the difference between the highest and the lowest Balance of Payment (as % of service exports) in Senegal?
Your answer should be very brief. 9.69. What is the difference between the highest and the lowest Balance of Payment (as % of service exports) in Ukraine?
Your answer should be compact. 4.86. 